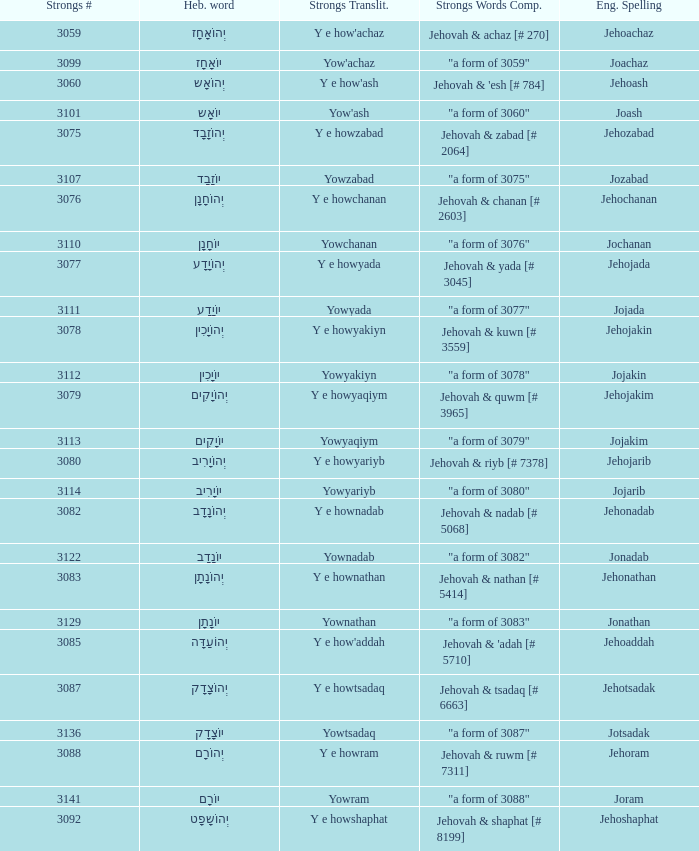What is the english spelling of the word that has the strongs trasliteration of y e howram? Jehoram. 